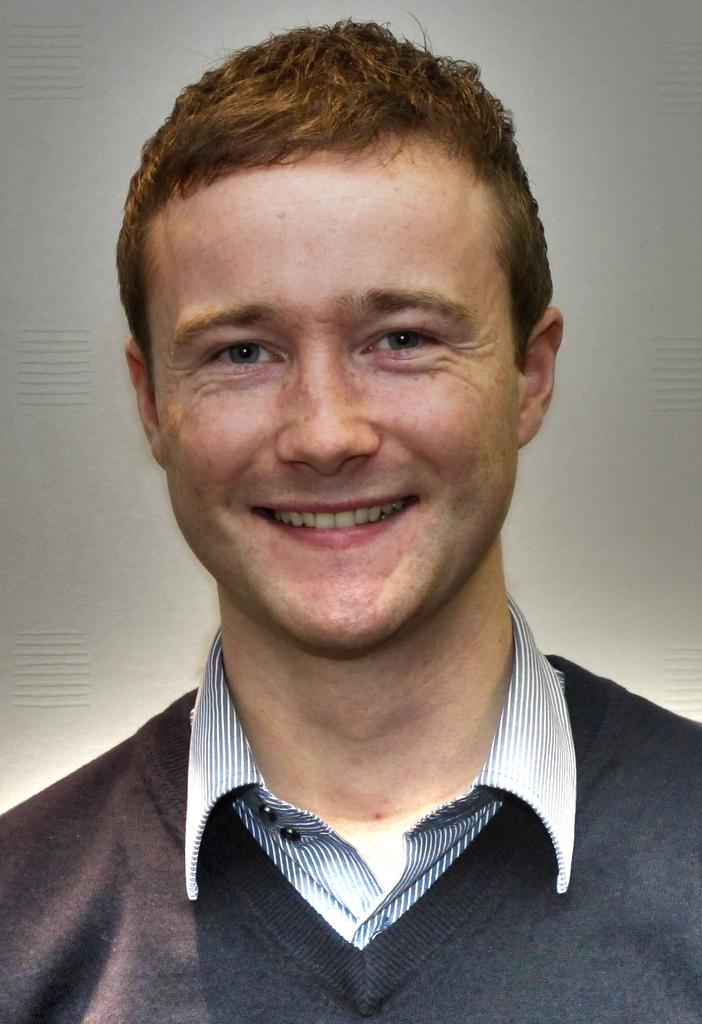What is the main subject of the picture? The main subject of the picture is a man. What is the man doing in the image? The man is smiling in the image. What color is the background of the image? The background of the image is white. What type of battle is taking place in the background of the image? There is no battle present in the image; the background is white. What role does the man's hand play in the image? The man's hand is not mentioned in the image, as the facts only mention that he is smiling. 